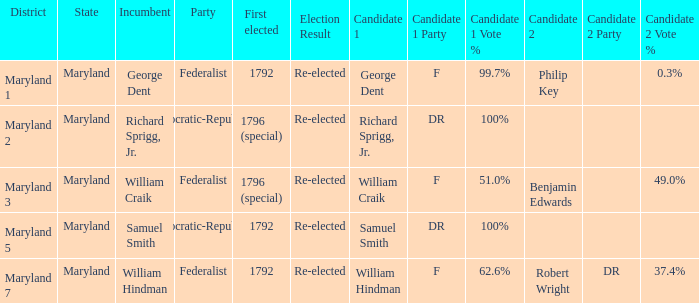Who is the candidates for district maryland 1? George Dent (F) 99.7% Philip Key 0.3%. 